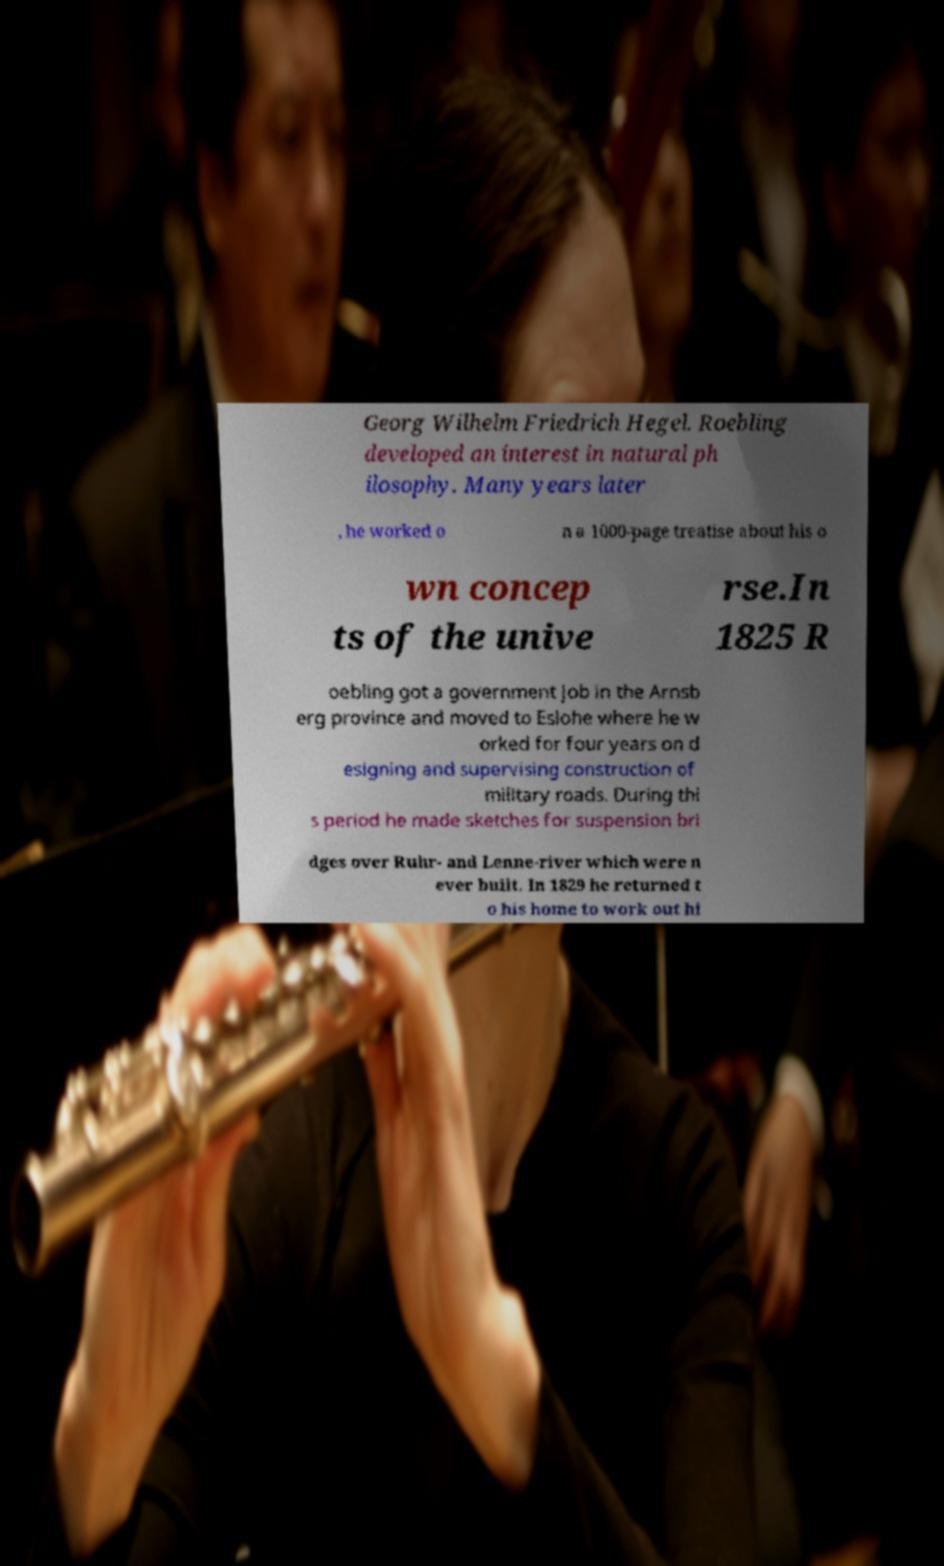Please read and relay the text visible in this image. What does it say? Georg Wilhelm Friedrich Hegel. Roebling developed an interest in natural ph ilosophy. Many years later , he worked o n a 1000-page treatise about his o wn concep ts of the unive rse.In 1825 R oebling got a government job in the Arnsb erg province and moved to Eslohe where he w orked for four years on d esigning and supervising construction of military roads. During thi s period he made sketches for suspension bri dges over Ruhr- and Lenne-river which were n ever built. In 1829 he returned t o his home to work out hi 